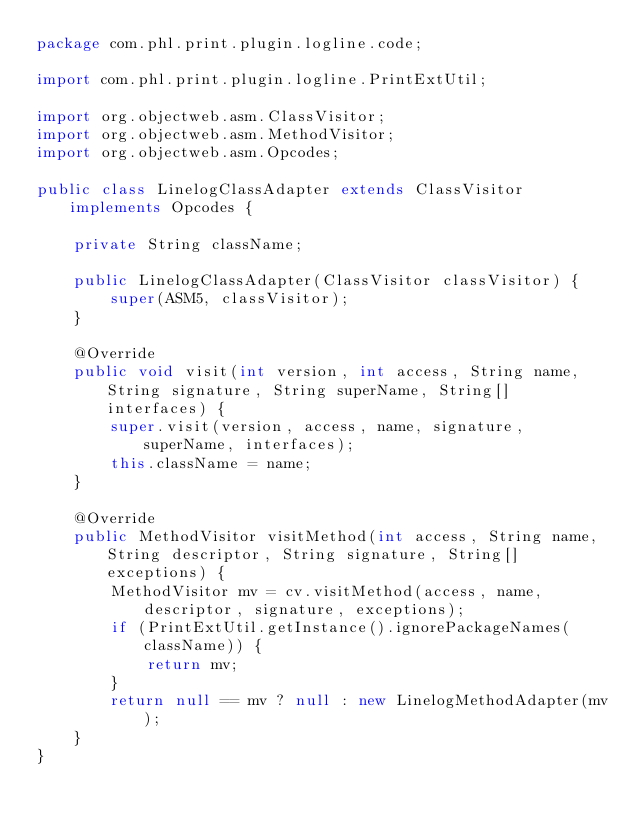<code> <loc_0><loc_0><loc_500><loc_500><_Java_>package com.phl.print.plugin.logline.code;

import com.phl.print.plugin.logline.PrintExtUtil;

import org.objectweb.asm.ClassVisitor;
import org.objectweb.asm.MethodVisitor;
import org.objectweb.asm.Opcodes;

public class LinelogClassAdapter extends ClassVisitor implements Opcodes {

    private String className;

    public LinelogClassAdapter(ClassVisitor classVisitor) {
        super(ASM5, classVisitor);
    }

    @Override
    public void visit(int version, int access, String name, String signature, String superName, String[] interfaces) {
        super.visit(version, access, name, signature, superName, interfaces);
        this.className = name;
    }

    @Override
    public MethodVisitor visitMethod(int access, String name, String descriptor, String signature, String[] exceptions) {
        MethodVisitor mv = cv.visitMethod(access, name, descriptor, signature, exceptions);
        if (PrintExtUtil.getInstance().ignorePackageNames(className)) {
            return mv;
        }
        return null == mv ? null : new LinelogMethodAdapter(mv);
    }
}
</code> 